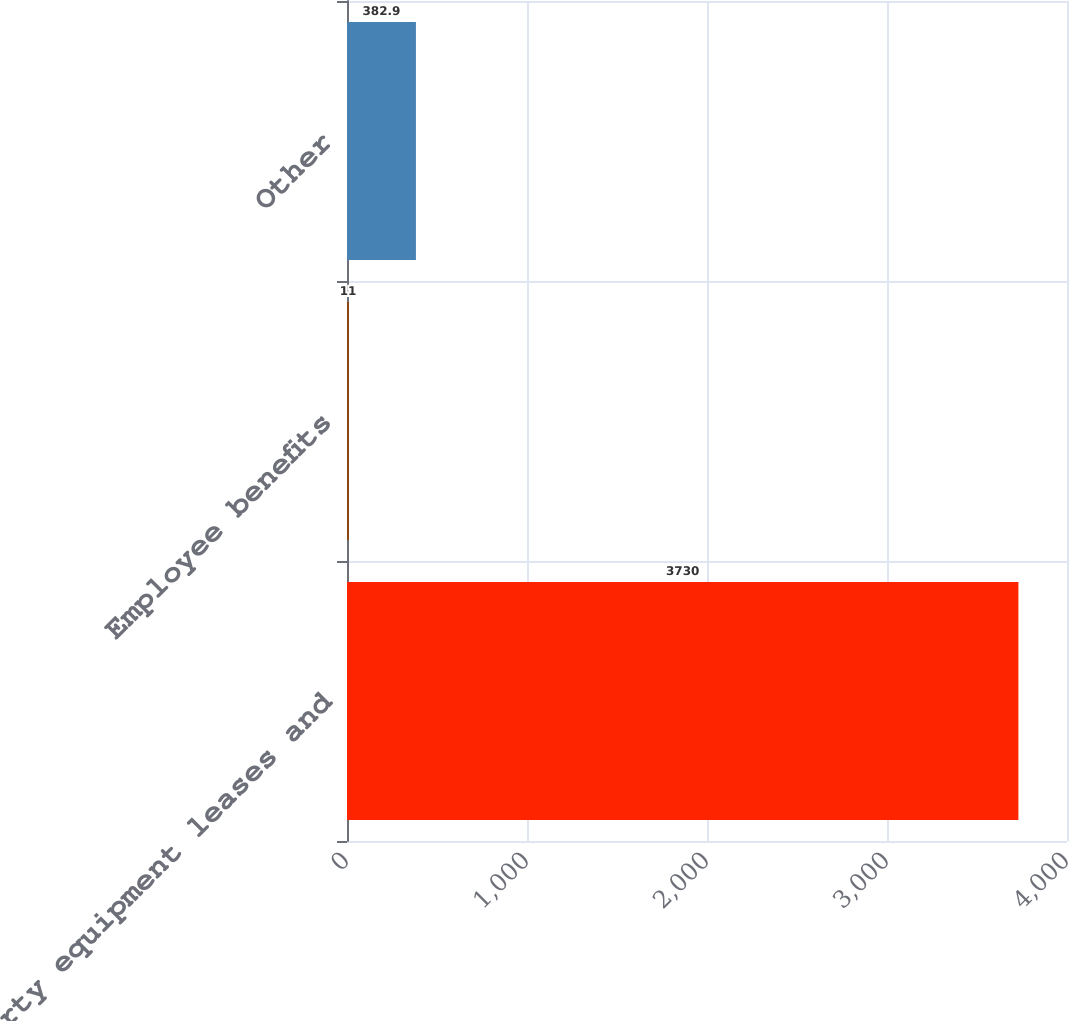Convert chart. <chart><loc_0><loc_0><loc_500><loc_500><bar_chart><fcel>Property equipment leases and<fcel>Employee benefits<fcel>Other<nl><fcel>3730<fcel>11<fcel>382.9<nl></chart> 